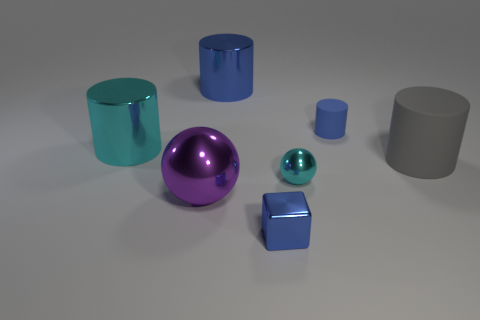Add 2 shiny objects. How many objects exist? 9 Subtract all blocks. How many objects are left? 6 Subtract all gray spheres. Subtract all small blue rubber objects. How many objects are left? 6 Add 1 cyan metal objects. How many cyan metal objects are left? 3 Add 5 big balls. How many big balls exist? 6 Subtract 0 gray spheres. How many objects are left? 7 